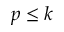Convert formula to latex. <formula><loc_0><loc_0><loc_500><loc_500>p \leq k</formula> 